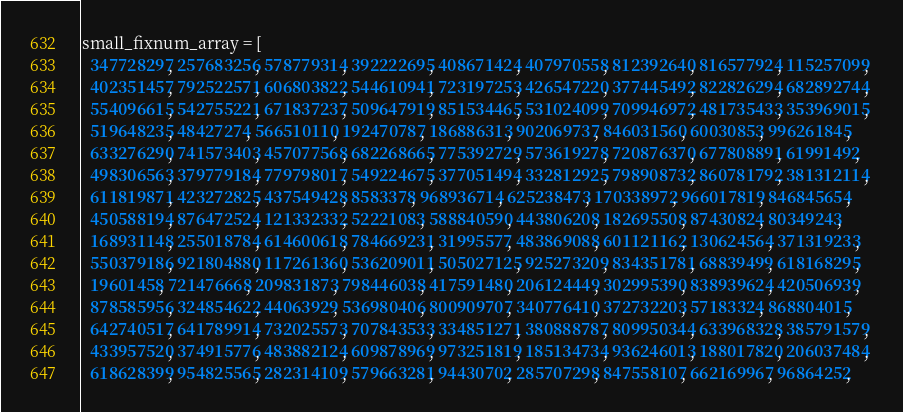Convert code to text. <code><loc_0><loc_0><loc_500><loc_500><_Ruby_>small_fixnum_array = [
  347728297, 257683256, 578779314, 392222695, 408671424, 407970558, 812392640, 816577924, 115257099, 
  402351457, 792522571, 606803822, 544610941, 723197253, 426547220, 377445492, 822826294, 682892744, 
  554096615, 542755221, 671837237, 509647919, 851534465, 531024099, 709946972, 481735433, 353969015, 
  519648235, 48427274, 566510110, 192470787, 186886313, 902069737, 846031560, 60030853, 996261845, 
  633276290, 741573403, 457077568, 682268665, 775392729, 573619278, 720876370, 677808891, 61991492, 
  498306563, 379779184, 779798017, 549224675, 377051494, 332812925, 798908732, 860781792, 381312114, 
  611819871, 423272825, 437549428, 8583378, 968936714, 625238473, 170338972, 966017819, 846845654, 
  450588194, 876472524, 121332332, 52221083, 588840590, 443806208, 182695508, 87430824, 80349243, 
  168931148, 255018784, 614600618, 784669231, 31995577, 483869088, 601121162, 130624564, 371319233, 
  550379186, 921804880, 117261360, 536209011, 505027125, 925273209, 834351781, 68839499, 618168295, 
  19601458, 721476668, 209831873, 798446038, 417591480, 206124449, 302995390, 838939624, 420506939, 
  878585956, 324854622, 44063929, 536980406, 800909707, 340776410, 372732203, 57183324, 868804015, 
  642740517, 641789914, 732025573, 707843533, 334851271, 380888787, 809950344, 633968328, 385791579, 
  433957520, 374915776, 483882124, 609878969, 973251819, 185134734, 936246013, 188017820, 206037484, 
  618628399, 954825565, 282314109, 579663281, 94430702, 285707298, 847558107, 662169967, 96864252, </code> 